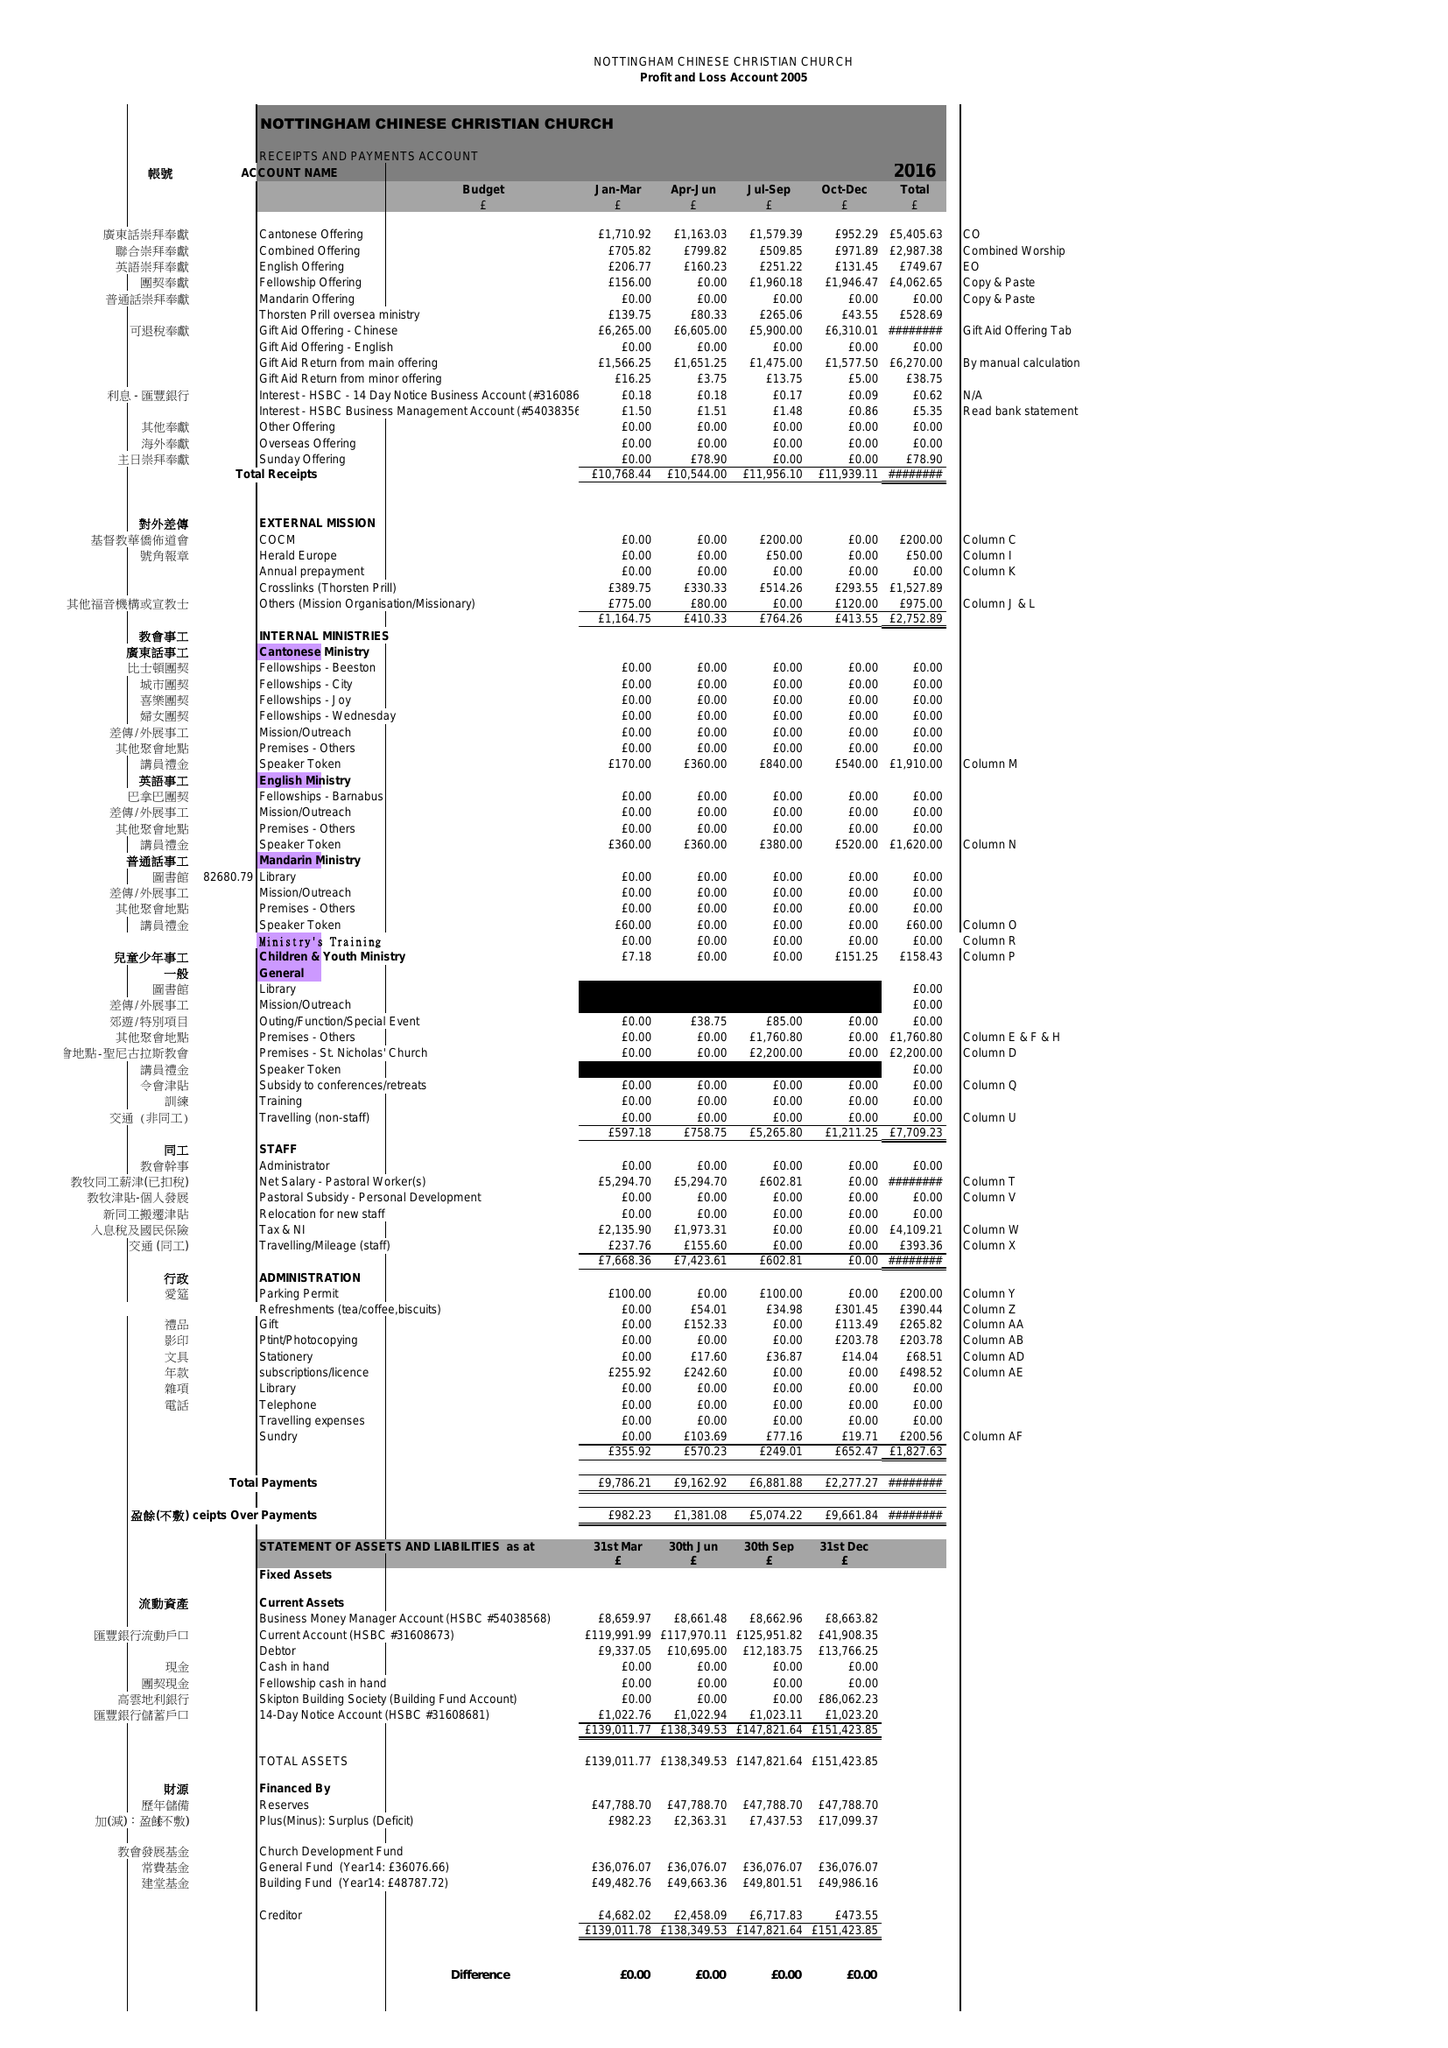What is the value for the spending_annually_in_british_pounds?
Answer the question using a single word or phrase. 28108.00 